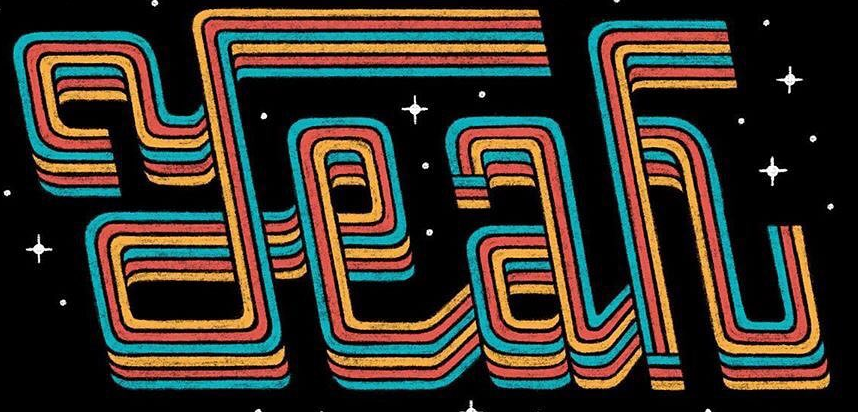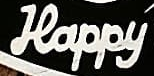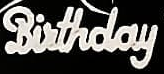What text is displayed in these images sequentially, separated by a semicolon? Yeah; Happy; Birthday 